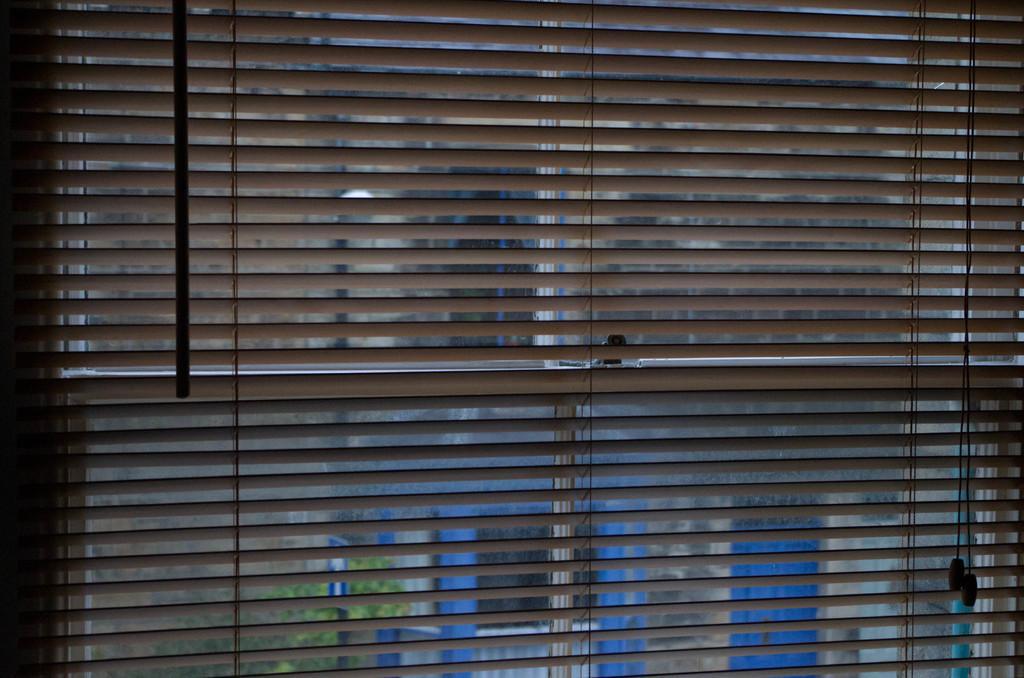Could you give a brief overview of what you see in this image? In this image I can see the window blind. Through the window I can see the tree and an another building. 